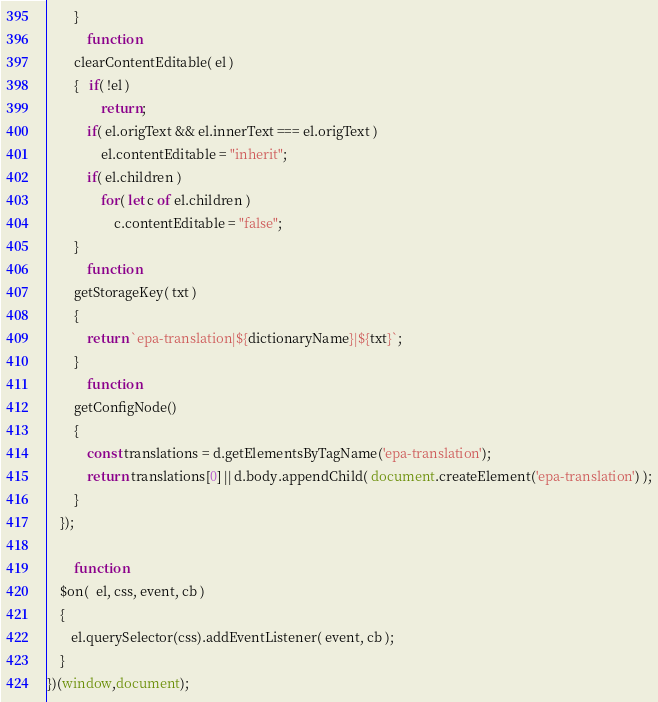<code> <loc_0><loc_0><loc_500><loc_500><_JavaScript_>        }
            function
        clearContentEditable( el )
        {   if( !el )
                return;
            if( el.origText && el.innerText === el.origText )
                el.contentEditable = "inherit";
            if( el.children )
                for( let c of el.children )
                    c.contentEditable = "false";
        }
            function
        getStorageKey( txt )
        {
            return `epa-translation|${dictionaryName}|${txt}`;
        }
            function
        getConfigNode()
        {
            const translations = d.getElementsByTagName('epa-translation');
            return translations[0] || d.body.appendChild( document.createElement('epa-translation') );
        }
    });

        function
    $on(  el, css, event, cb )
    {
       el.querySelector(css).addEventListener( event, cb );
    }
})(window,document);</code> 